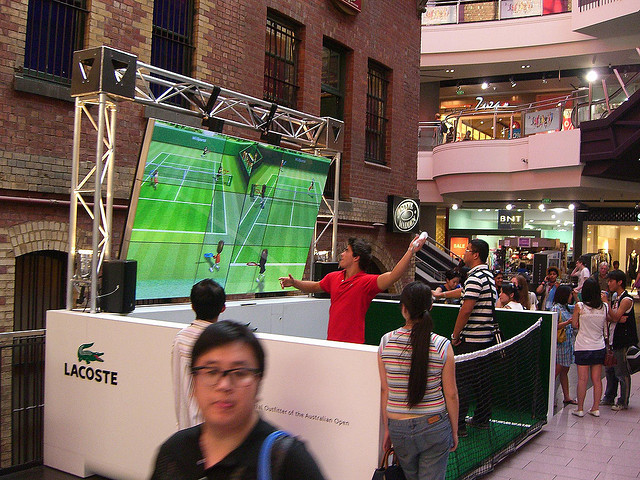Please identify all text content in this image. LACOSTE BNT 